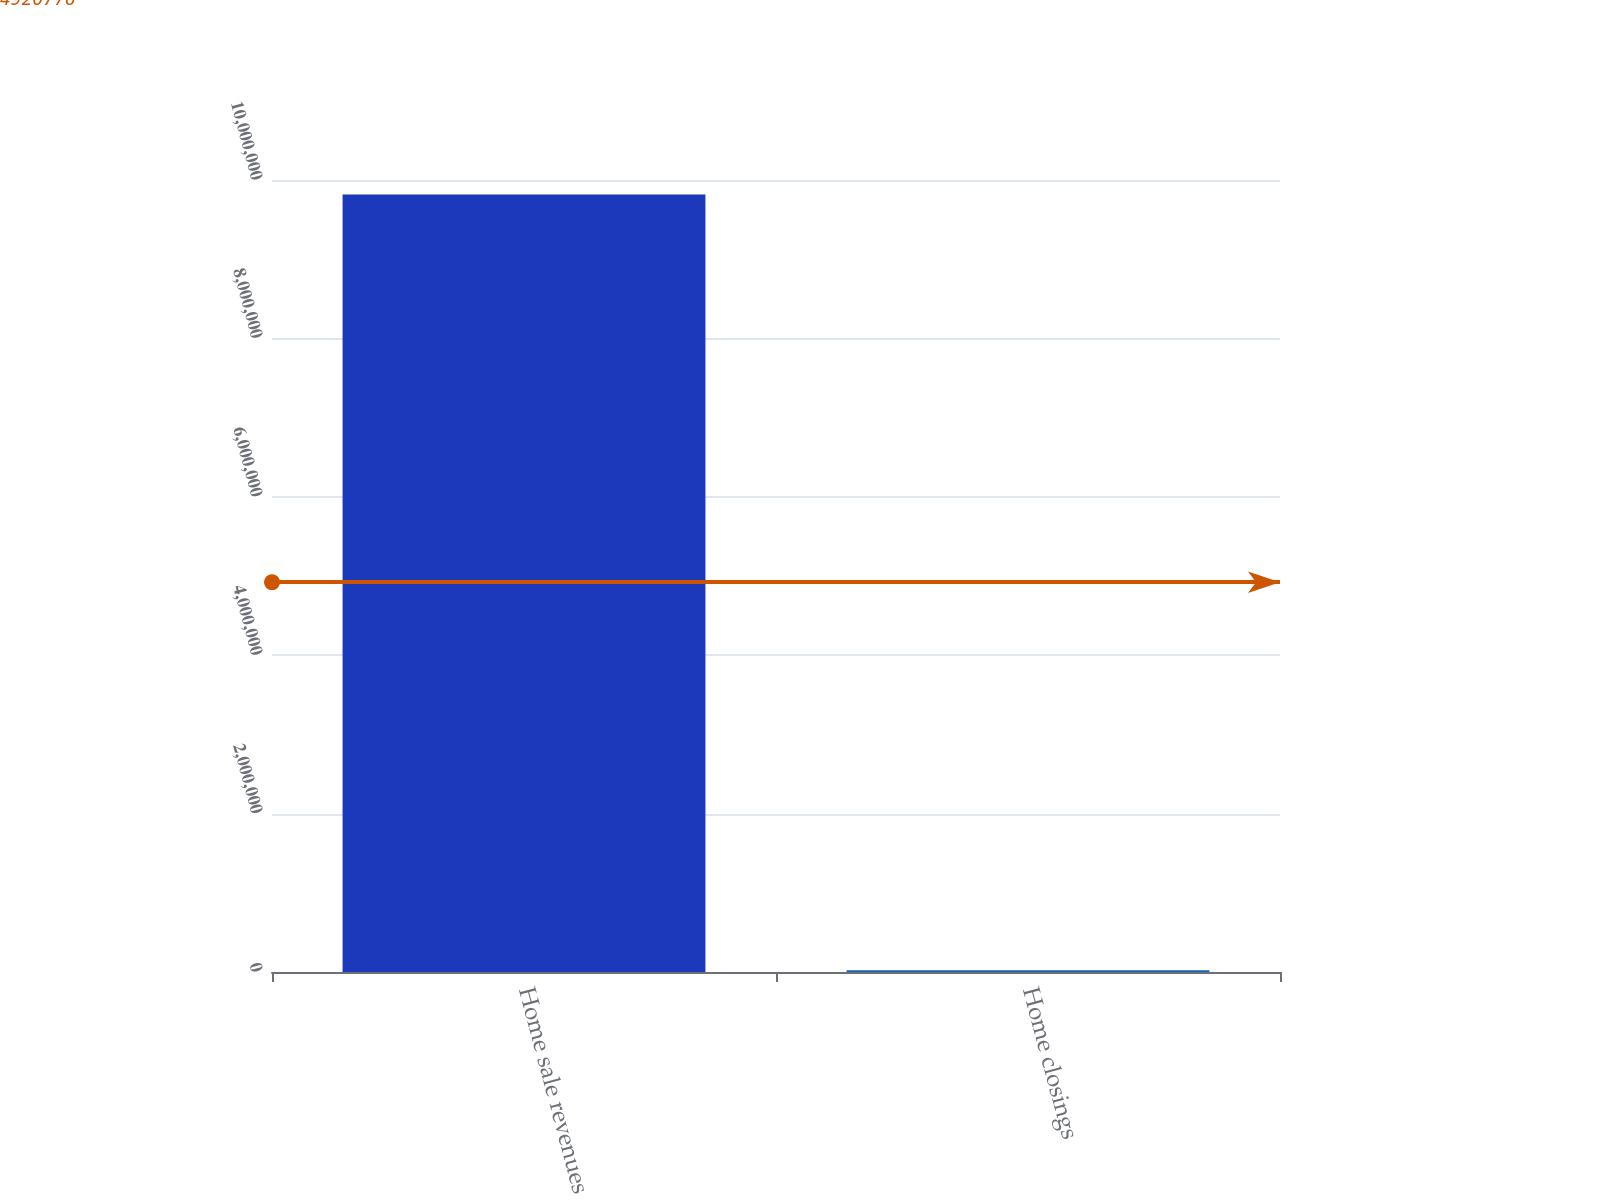Convert chart to OTSL. <chart><loc_0><loc_0><loc_500><loc_500><bar_chart><fcel>Home sale revenues<fcel>Home closings<nl><fcel>9.81844e+06<fcel>23107<nl></chart> 